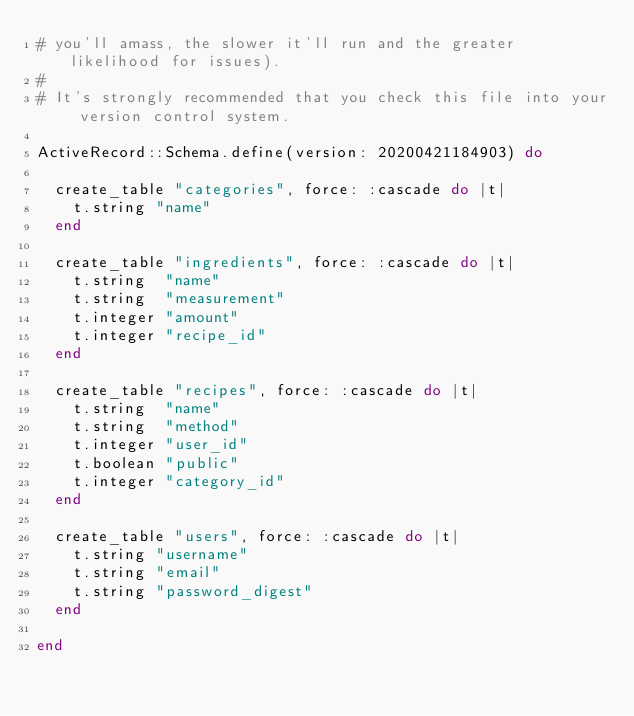<code> <loc_0><loc_0><loc_500><loc_500><_Ruby_># you'll amass, the slower it'll run and the greater likelihood for issues).
#
# It's strongly recommended that you check this file into your version control system.

ActiveRecord::Schema.define(version: 20200421184903) do

  create_table "categories", force: :cascade do |t|
    t.string "name"
  end

  create_table "ingredients", force: :cascade do |t|
    t.string  "name"
    t.string  "measurement"
    t.integer "amount"
    t.integer "recipe_id"
  end

  create_table "recipes", force: :cascade do |t|
    t.string  "name"
    t.string  "method"
    t.integer "user_id"
    t.boolean "public"
    t.integer "category_id"
  end

  create_table "users", force: :cascade do |t|
    t.string "username"
    t.string "email"
    t.string "password_digest"
  end

end
</code> 